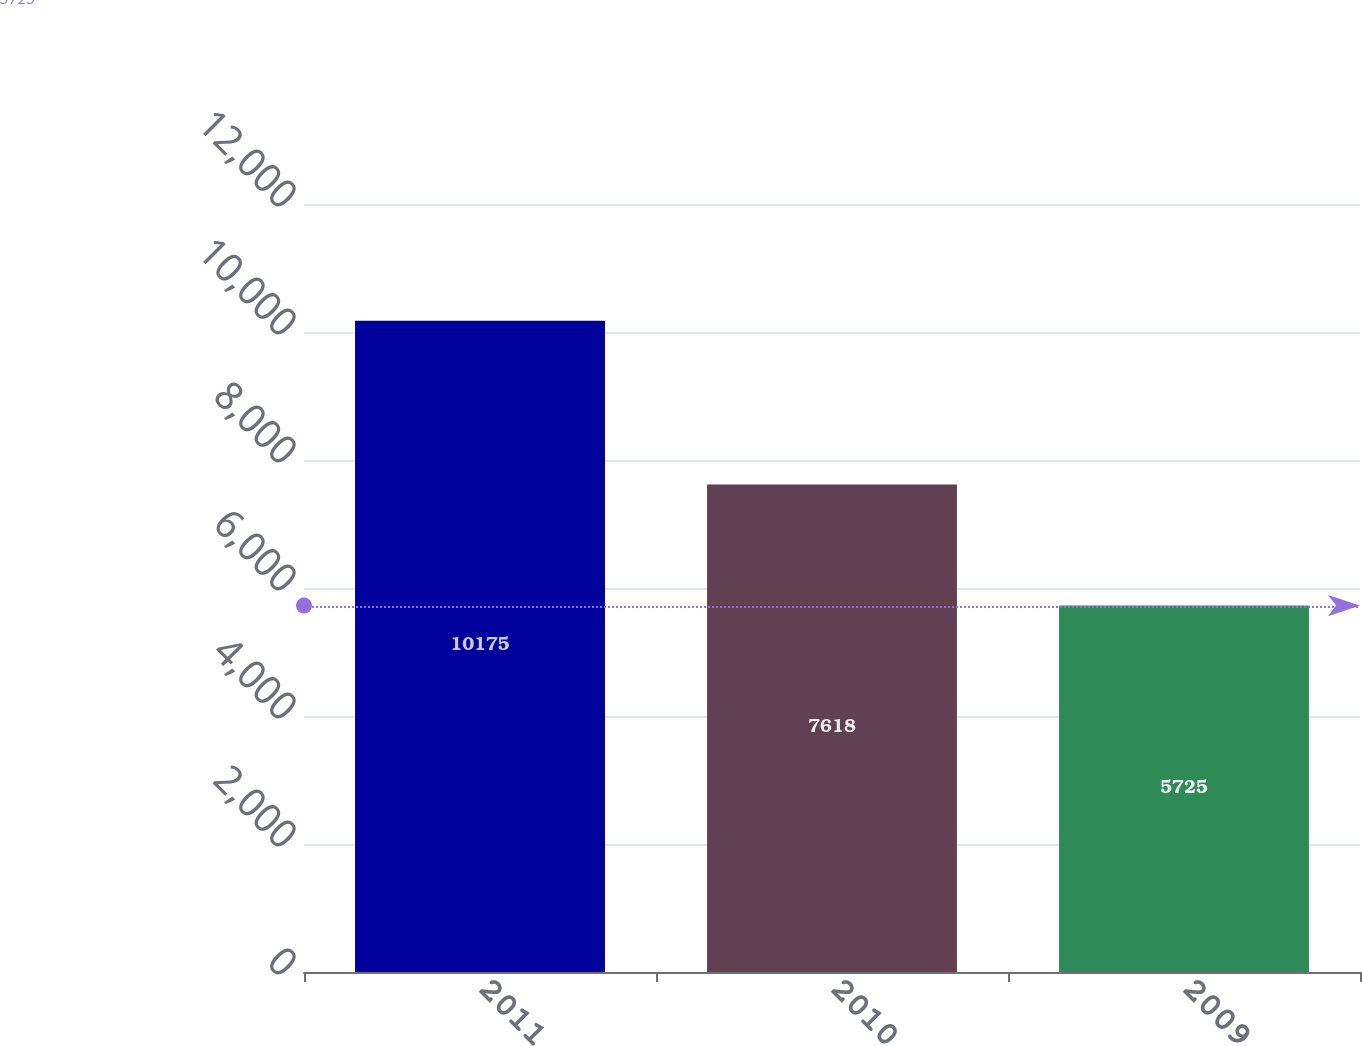<chart> <loc_0><loc_0><loc_500><loc_500><bar_chart><fcel>2011<fcel>2010<fcel>2009<nl><fcel>10175<fcel>7618<fcel>5725<nl></chart> 